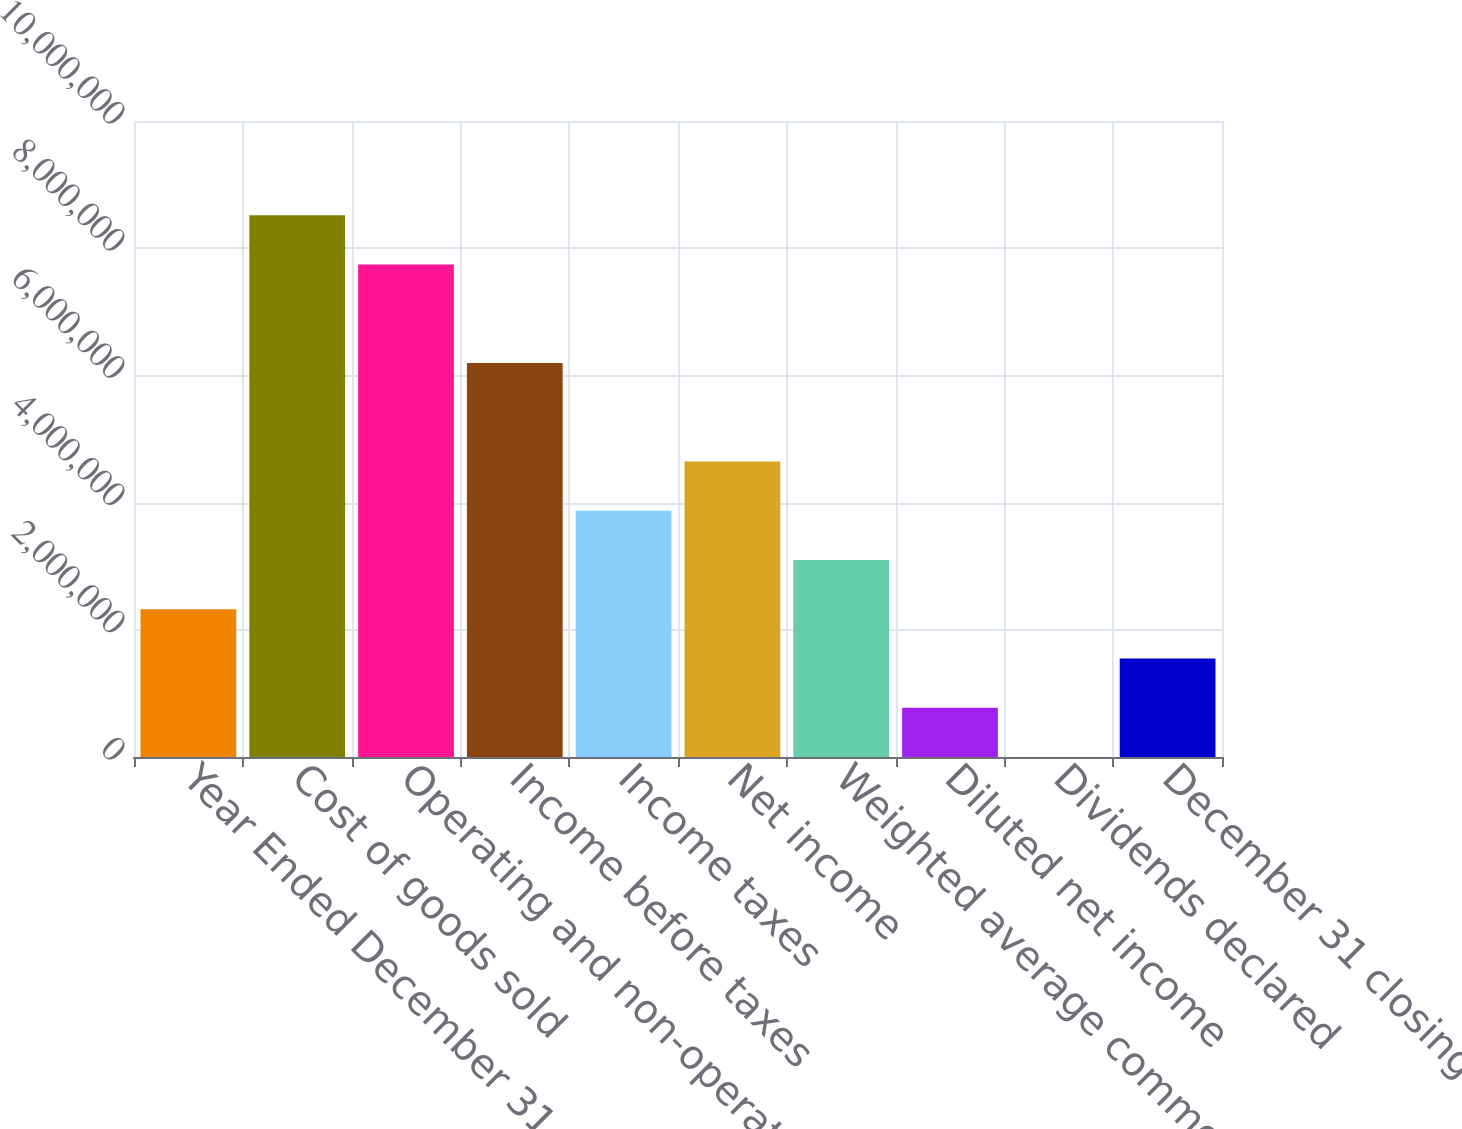Convert chart. <chart><loc_0><loc_0><loc_500><loc_500><bar_chart><fcel>Year Ended December 31<fcel>Cost of goods sold<fcel>Operating and non-operating<fcel>Income before taxes<fcel>Income taxes<fcel>Net income<fcel>Weighted average common shares<fcel>Diluted net income<fcel>Dividends declared<fcel>December 31 closing stock<nl><fcel>2.32283e+06<fcel>8.51705e+06<fcel>7.74277e+06<fcel>6.19422e+06<fcel>3.87139e+06<fcel>4.64566e+06<fcel>3.09711e+06<fcel>774279<fcel>1.56<fcel>1.54856e+06<nl></chart> 